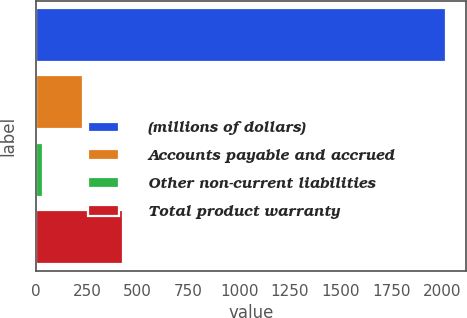<chart> <loc_0><loc_0><loc_500><loc_500><bar_chart><fcel>(millions of dollars)<fcel>Accounts payable and accrued<fcel>Other non-current liabilities<fcel>Total product warranty<nl><fcel>2016<fcel>229.86<fcel>31.4<fcel>428.32<nl></chart> 